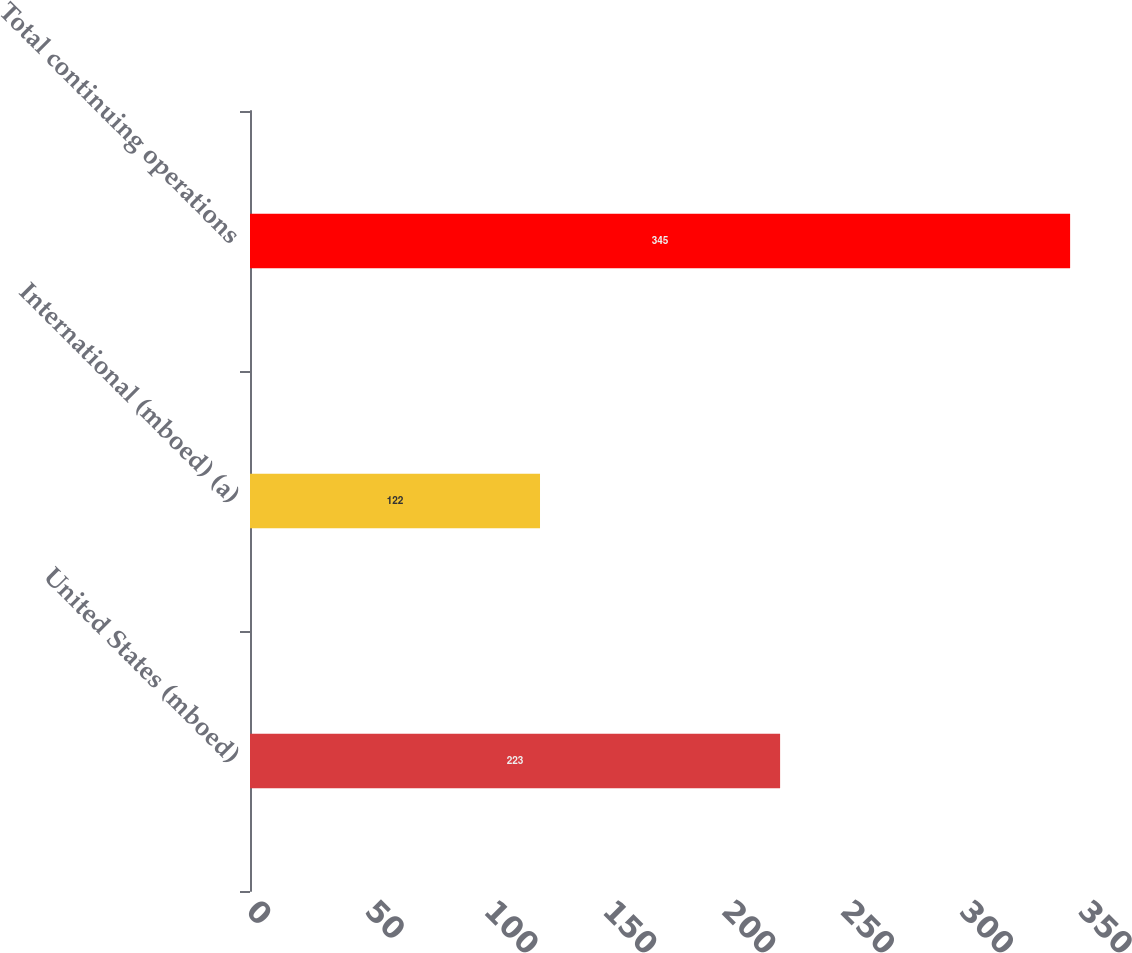Convert chart. <chart><loc_0><loc_0><loc_500><loc_500><bar_chart><fcel>United States (mboed)<fcel>International (mboed) (a)<fcel>Total continuing operations<nl><fcel>223<fcel>122<fcel>345<nl></chart> 